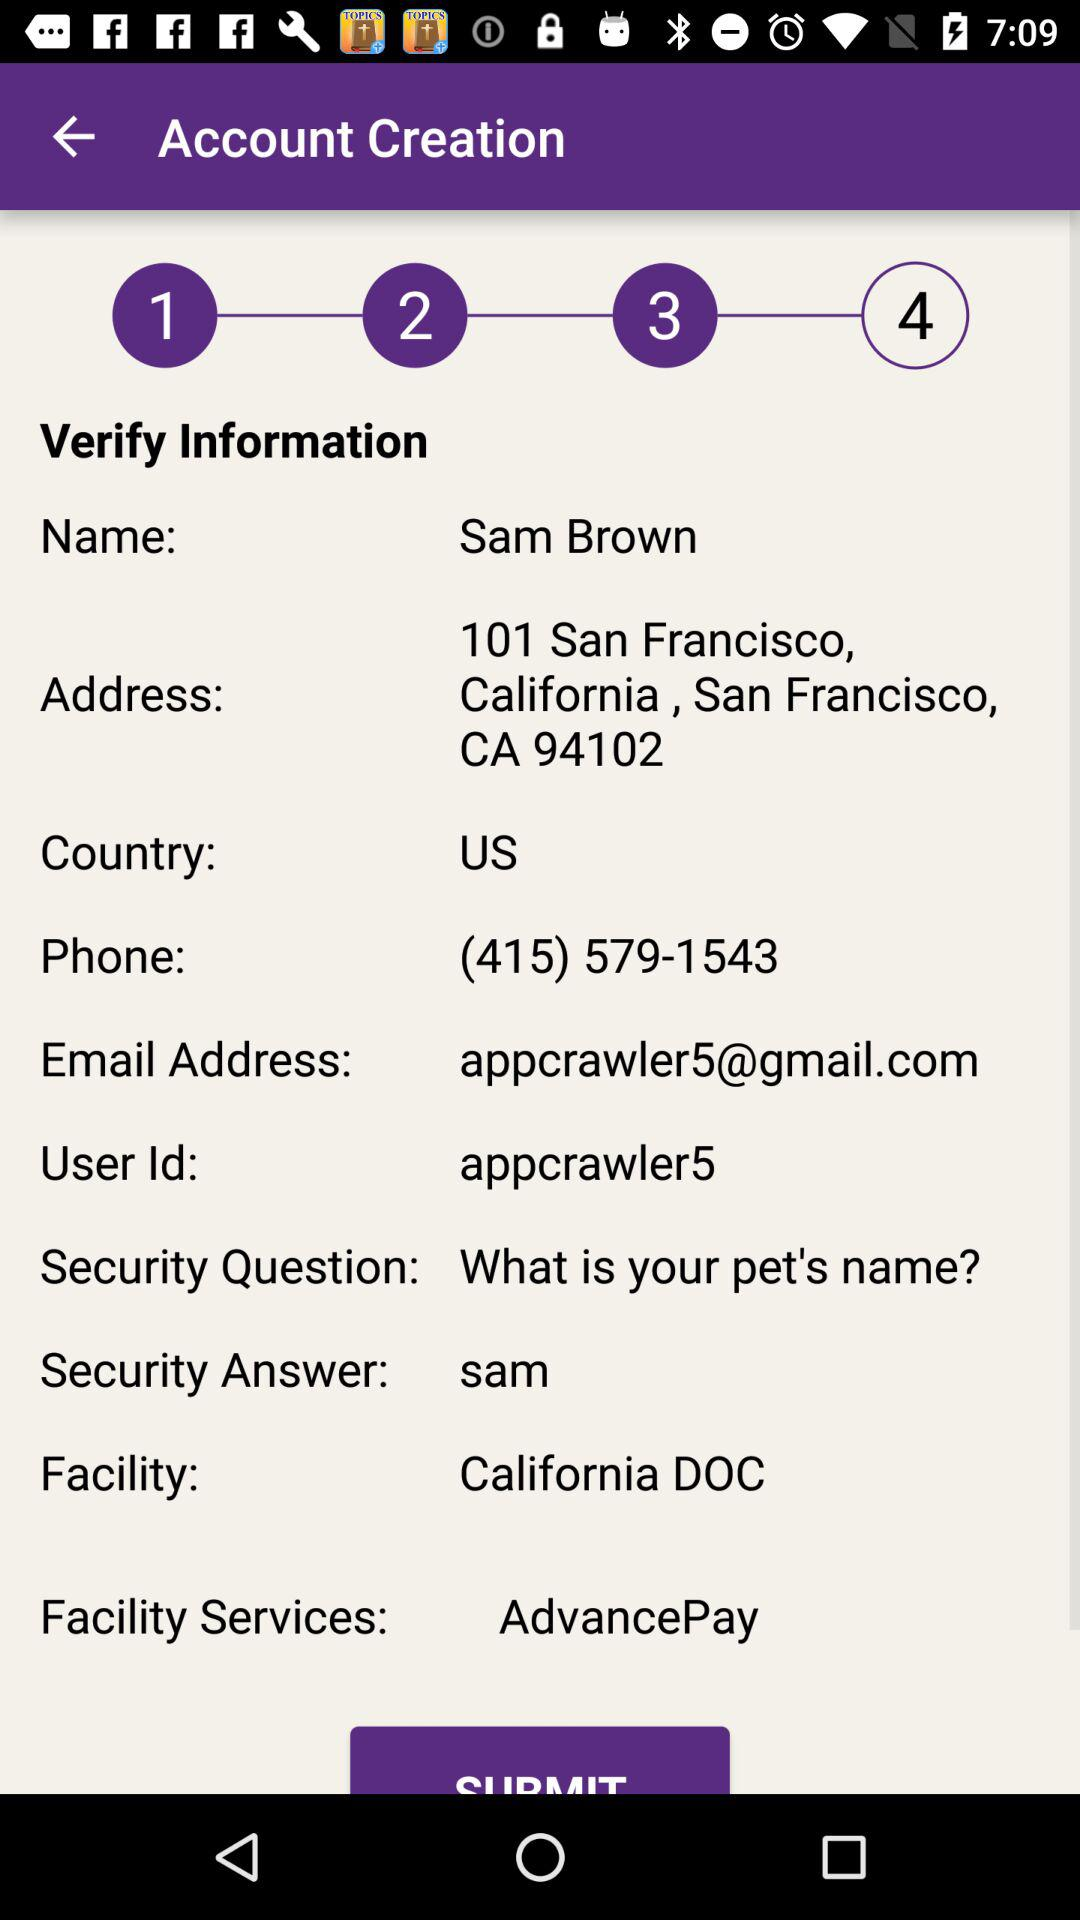What is the security answer? The security answer is "sam". 